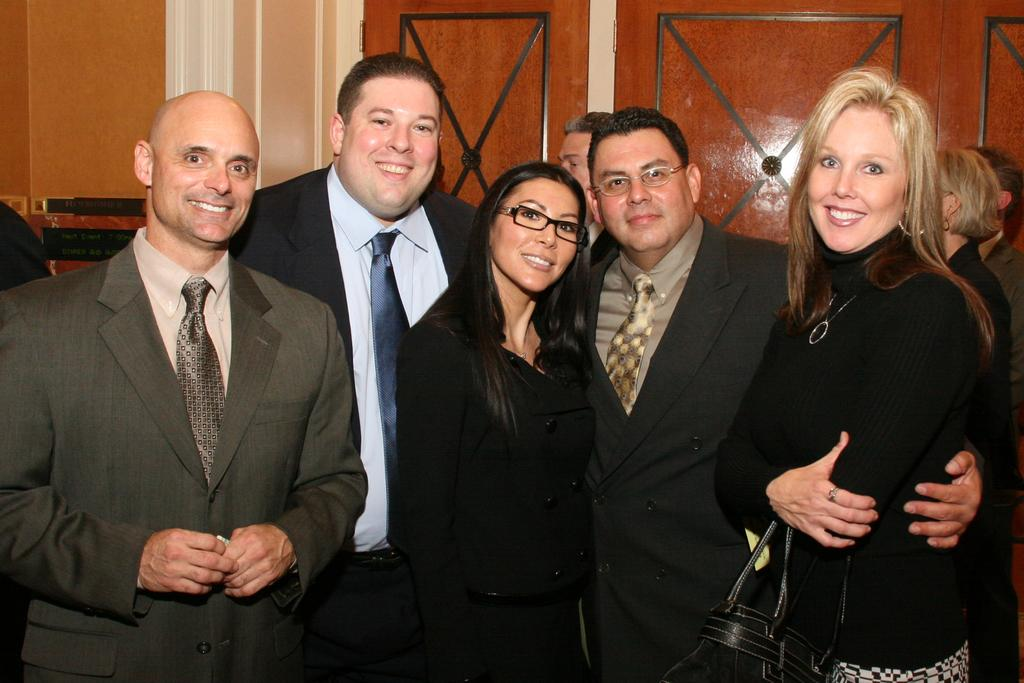How many people are in the image? There is a group of people in the image. Can you describe the clothing of one of the people in the group? One person in the group is wearing a black dress. What color are the doors visible in the background of the image? There are brown-colored doors in the background of the image. What type of linen is being used to cover the drawer in the image? There is no drawer or linen present in the image. What kind of shoes are the people wearing in the image? The provided facts do not mention the type of shoes the people are wearing, so we cannot answer this question definitively. 